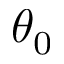Convert formula to latex. <formula><loc_0><loc_0><loc_500><loc_500>\theta _ { 0 }</formula> 